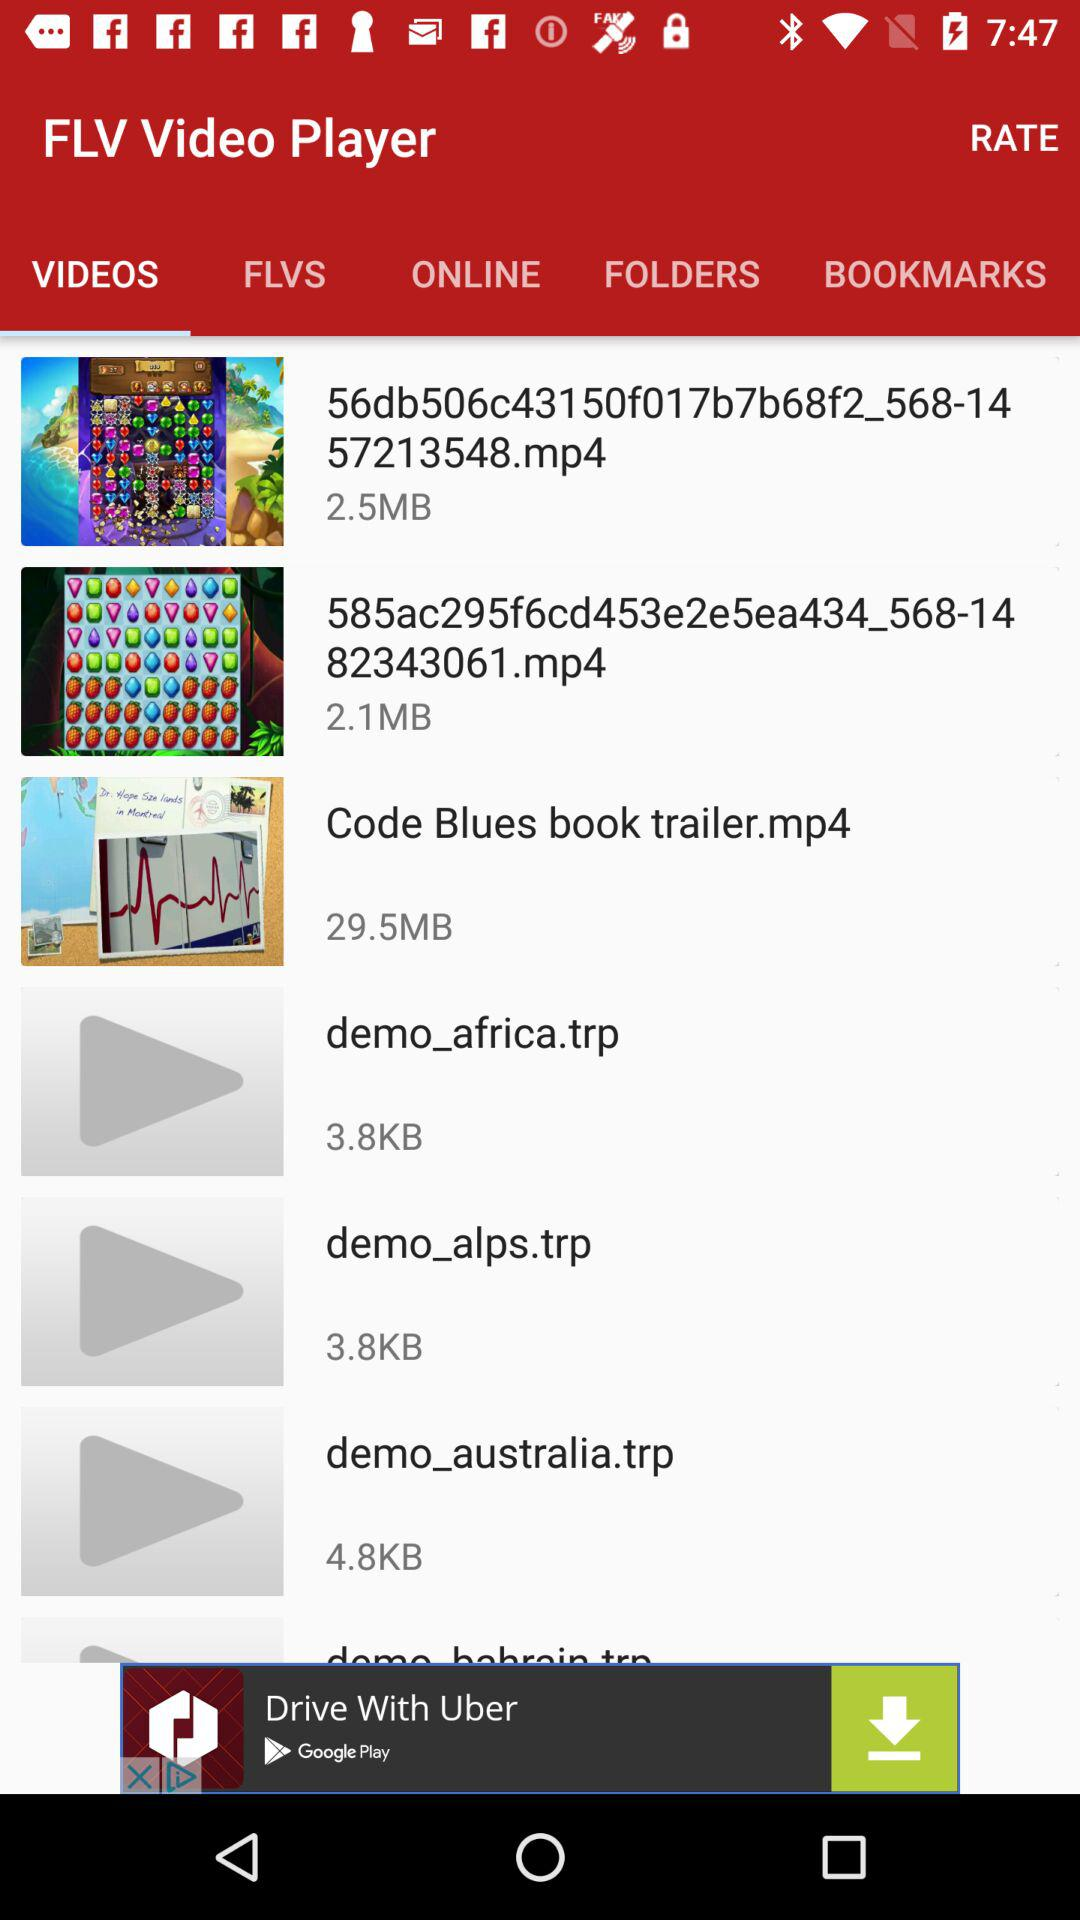What is the selected tab? The selected tab is "VIDEOS". 